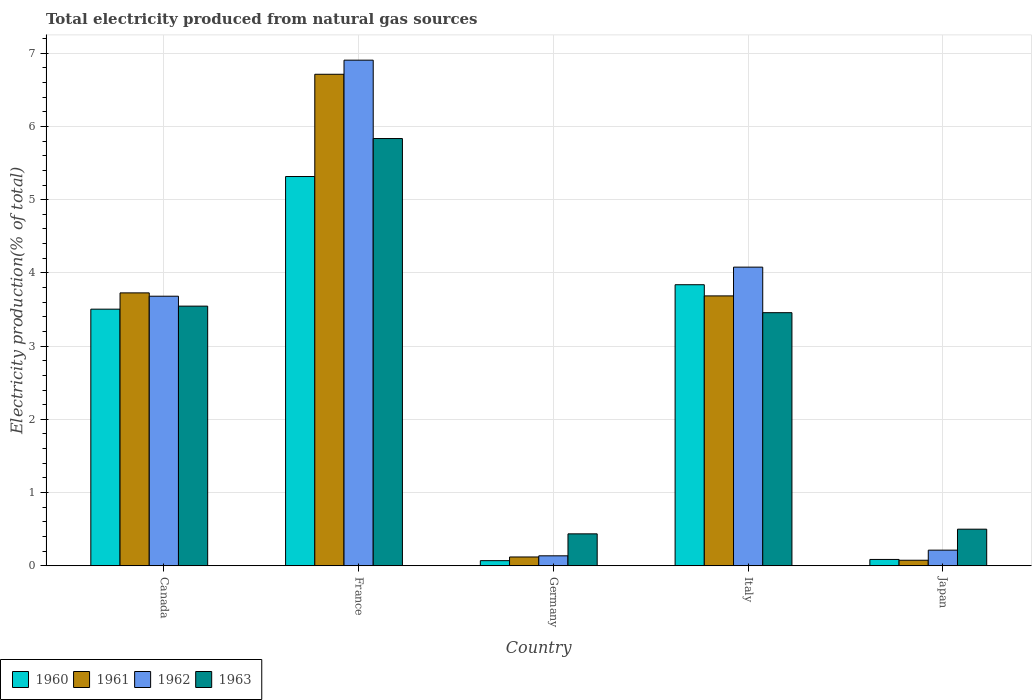How many different coloured bars are there?
Keep it short and to the point. 4. How many bars are there on the 4th tick from the right?
Make the answer very short. 4. What is the total electricity produced in 1961 in Japan?
Your answer should be compact. 0.08. Across all countries, what is the maximum total electricity produced in 1962?
Offer a terse response. 6.91. Across all countries, what is the minimum total electricity produced in 1961?
Offer a very short reply. 0.08. In which country was the total electricity produced in 1961 minimum?
Offer a very short reply. Japan. What is the total total electricity produced in 1963 in the graph?
Offer a terse response. 13.77. What is the difference between the total electricity produced in 1963 in Italy and that in Japan?
Your response must be concise. 2.96. What is the difference between the total electricity produced in 1962 in France and the total electricity produced in 1960 in Germany?
Your response must be concise. 6.83. What is the average total electricity produced in 1960 per country?
Provide a succinct answer. 2.56. What is the difference between the total electricity produced of/in 1962 and total electricity produced of/in 1961 in Germany?
Offer a very short reply. 0.02. What is the ratio of the total electricity produced in 1962 in France to that in Germany?
Provide a short and direct response. 50.69. What is the difference between the highest and the second highest total electricity produced in 1962?
Keep it short and to the point. -0.4. What is the difference between the highest and the lowest total electricity produced in 1963?
Offer a terse response. 5.4. In how many countries, is the total electricity produced in 1963 greater than the average total electricity produced in 1963 taken over all countries?
Provide a succinct answer. 3. Is the sum of the total electricity produced in 1962 in France and Japan greater than the maximum total electricity produced in 1963 across all countries?
Offer a terse response. Yes. Is it the case that in every country, the sum of the total electricity produced in 1960 and total electricity produced in 1963 is greater than the sum of total electricity produced in 1962 and total electricity produced in 1961?
Offer a terse response. No. What does the 4th bar from the left in Germany represents?
Your answer should be very brief. 1963. What does the 4th bar from the right in Italy represents?
Your answer should be very brief. 1960. Are all the bars in the graph horizontal?
Your answer should be very brief. No. How many countries are there in the graph?
Your response must be concise. 5. Are the values on the major ticks of Y-axis written in scientific E-notation?
Your response must be concise. No. Does the graph contain any zero values?
Your response must be concise. No. Does the graph contain grids?
Make the answer very short. Yes. Where does the legend appear in the graph?
Offer a terse response. Bottom left. How many legend labels are there?
Your response must be concise. 4. How are the legend labels stacked?
Keep it short and to the point. Horizontal. What is the title of the graph?
Keep it short and to the point. Total electricity produced from natural gas sources. Does "1994" appear as one of the legend labels in the graph?
Your answer should be very brief. No. What is the Electricity production(% of total) in 1960 in Canada?
Your response must be concise. 3.5. What is the Electricity production(% of total) of 1961 in Canada?
Ensure brevity in your answer.  3.73. What is the Electricity production(% of total) in 1962 in Canada?
Make the answer very short. 3.68. What is the Electricity production(% of total) of 1963 in Canada?
Provide a short and direct response. 3.55. What is the Electricity production(% of total) of 1960 in France?
Ensure brevity in your answer.  5.32. What is the Electricity production(% of total) in 1961 in France?
Ensure brevity in your answer.  6.71. What is the Electricity production(% of total) in 1962 in France?
Your answer should be very brief. 6.91. What is the Electricity production(% of total) in 1963 in France?
Your answer should be compact. 5.83. What is the Electricity production(% of total) in 1960 in Germany?
Keep it short and to the point. 0.07. What is the Electricity production(% of total) in 1961 in Germany?
Provide a succinct answer. 0.12. What is the Electricity production(% of total) of 1962 in Germany?
Make the answer very short. 0.14. What is the Electricity production(% of total) of 1963 in Germany?
Your answer should be very brief. 0.44. What is the Electricity production(% of total) in 1960 in Italy?
Keep it short and to the point. 3.84. What is the Electricity production(% of total) of 1961 in Italy?
Give a very brief answer. 3.69. What is the Electricity production(% of total) of 1962 in Italy?
Ensure brevity in your answer.  4.08. What is the Electricity production(% of total) of 1963 in Italy?
Keep it short and to the point. 3.46. What is the Electricity production(% of total) of 1960 in Japan?
Your response must be concise. 0.09. What is the Electricity production(% of total) of 1961 in Japan?
Your response must be concise. 0.08. What is the Electricity production(% of total) of 1962 in Japan?
Make the answer very short. 0.21. What is the Electricity production(% of total) of 1963 in Japan?
Offer a very short reply. 0.5. Across all countries, what is the maximum Electricity production(% of total) of 1960?
Keep it short and to the point. 5.32. Across all countries, what is the maximum Electricity production(% of total) in 1961?
Offer a terse response. 6.71. Across all countries, what is the maximum Electricity production(% of total) in 1962?
Give a very brief answer. 6.91. Across all countries, what is the maximum Electricity production(% of total) of 1963?
Provide a short and direct response. 5.83. Across all countries, what is the minimum Electricity production(% of total) of 1960?
Provide a succinct answer. 0.07. Across all countries, what is the minimum Electricity production(% of total) of 1961?
Provide a short and direct response. 0.08. Across all countries, what is the minimum Electricity production(% of total) of 1962?
Make the answer very short. 0.14. Across all countries, what is the minimum Electricity production(% of total) of 1963?
Make the answer very short. 0.44. What is the total Electricity production(% of total) in 1960 in the graph?
Provide a short and direct response. 12.82. What is the total Electricity production(% of total) in 1961 in the graph?
Give a very brief answer. 14.32. What is the total Electricity production(% of total) of 1962 in the graph?
Provide a succinct answer. 15.01. What is the total Electricity production(% of total) of 1963 in the graph?
Your response must be concise. 13.77. What is the difference between the Electricity production(% of total) in 1960 in Canada and that in France?
Provide a short and direct response. -1.81. What is the difference between the Electricity production(% of total) of 1961 in Canada and that in France?
Offer a very short reply. -2.99. What is the difference between the Electricity production(% of total) in 1962 in Canada and that in France?
Your response must be concise. -3.22. What is the difference between the Electricity production(% of total) of 1963 in Canada and that in France?
Offer a very short reply. -2.29. What is the difference between the Electricity production(% of total) in 1960 in Canada and that in Germany?
Provide a short and direct response. 3.43. What is the difference between the Electricity production(% of total) in 1961 in Canada and that in Germany?
Ensure brevity in your answer.  3.61. What is the difference between the Electricity production(% of total) in 1962 in Canada and that in Germany?
Make the answer very short. 3.55. What is the difference between the Electricity production(% of total) in 1963 in Canada and that in Germany?
Offer a very short reply. 3.11. What is the difference between the Electricity production(% of total) of 1960 in Canada and that in Italy?
Ensure brevity in your answer.  -0.33. What is the difference between the Electricity production(% of total) of 1961 in Canada and that in Italy?
Ensure brevity in your answer.  0.04. What is the difference between the Electricity production(% of total) of 1962 in Canada and that in Italy?
Give a very brief answer. -0.4. What is the difference between the Electricity production(% of total) of 1963 in Canada and that in Italy?
Offer a very short reply. 0.09. What is the difference between the Electricity production(% of total) in 1960 in Canada and that in Japan?
Your response must be concise. 3.42. What is the difference between the Electricity production(% of total) in 1961 in Canada and that in Japan?
Give a very brief answer. 3.65. What is the difference between the Electricity production(% of total) of 1962 in Canada and that in Japan?
Provide a succinct answer. 3.47. What is the difference between the Electricity production(% of total) of 1963 in Canada and that in Japan?
Ensure brevity in your answer.  3.05. What is the difference between the Electricity production(% of total) of 1960 in France and that in Germany?
Offer a very short reply. 5.25. What is the difference between the Electricity production(% of total) in 1961 in France and that in Germany?
Your answer should be compact. 6.59. What is the difference between the Electricity production(% of total) of 1962 in France and that in Germany?
Your answer should be compact. 6.77. What is the difference between the Electricity production(% of total) of 1963 in France and that in Germany?
Give a very brief answer. 5.4. What is the difference between the Electricity production(% of total) in 1960 in France and that in Italy?
Provide a succinct answer. 1.48. What is the difference between the Electricity production(% of total) in 1961 in France and that in Italy?
Make the answer very short. 3.03. What is the difference between the Electricity production(% of total) of 1962 in France and that in Italy?
Ensure brevity in your answer.  2.83. What is the difference between the Electricity production(% of total) in 1963 in France and that in Italy?
Provide a short and direct response. 2.38. What is the difference between the Electricity production(% of total) of 1960 in France and that in Japan?
Make the answer very short. 5.23. What is the difference between the Electricity production(% of total) in 1961 in France and that in Japan?
Give a very brief answer. 6.64. What is the difference between the Electricity production(% of total) in 1962 in France and that in Japan?
Provide a short and direct response. 6.69. What is the difference between the Electricity production(% of total) of 1963 in France and that in Japan?
Offer a very short reply. 5.33. What is the difference between the Electricity production(% of total) of 1960 in Germany and that in Italy?
Make the answer very short. -3.77. What is the difference between the Electricity production(% of total) in 1961 in Germany and that in Italy?
Provide a succinct answer. -3.57. What is the difference between the Electricity production(% of total) in 1962 in Germany and that in Italy?
Offer a very short reply. -3.94. What is the difference between the Electricity production(% of total) of 1963 in Germany and that in Italy?
Offer a terse response. -3.02. What is the difference between the Electricity production(% of total) in 1960 in Germany and that in Japan?
Offer a terse response. -0.02. What is the difference between the Electricity production(% of total) of 1961 in Germany and that in Japan?
Your response must be concise. 0.04. What is the difference between the Electricity production(% of total) in 1962 in Germany and that in Japan?
Keep it short and to the point. -0.08. What is the difference between the Electricity production(% of total) in 1963 in Germany and that in Japan?
Provide a short and direct response. -0.06. What is the difference between the Electricity production(% of total) of 1960 in Italy and that in Japan?
Offer a terse response. 3.75. What is the difference between the Electricity production(% of total) of 1961 in Italy and that in Japan?
Your answer should be very brief. 3.61. What is the difference between the Electricity production(% of total) in 1962 in Italy and that in Japan?
Your answer should be compact. 3.86. What is the difference between the Electricity production(% of total) in 1963 in Italy and that in Japan?
Make the answer very short. 2.96. What is the difference between the Electricity production(% of total) in 1960 in Canada and the Electricity production(% of total) in 1961 in France?
Provide a succinct answer. -3.21. What is the difference between the Electricity production(% of total) of 1960 in Canada and the Electricity production(% of total) of 1962 in France?
Your response must be concise. -3.4. What is the difference between the Electricity production(% of total) in 1960 in Canada and the Electricity production(% of total) in 1963 in France?
Your answer should be compact. -2.33. What is the difference between the Electricity production(% of total) in 1961 in Canada and the Electricity production(% of total) in 1962 in France?
Offer a very short reply. -3.18. What is the difference between the Electricity production(% of total) in 1961 in Canada and the Electricity production(% of total) in 1963 in France?
Offer a terse response. -2.11. What is the difference between the Electricity production(% of total) in 1962 in Canada and the Electricity production(% of total) in 1963 in France?
Your answer should be compact. -2.15. What is the difference between the Electricity production(% of total) in 1960 in Canada and the Electricity production(% of total) in 1961 in Germany?
Offer a very short reply. 3.38. What is the difference between the Electricity production(% of total) in 1960 in Canada and the Electricity production(% of total) in 1962 in Germany?
Give a very brief answer. 3.37. What is the difference between the Electricity production(% of total) of 1960 in Canada and the Electricity production(% of total) of 1963 in Germany?
Make the answer very short. 3.07. What is the difference between the Electricity production(% of total) in 1961 in Canada and the Electricity production(% of total) in 1962 in Germany?
Keep it short and to the point. 3.59. What is the difference between the Electricity production(% of total) in 1961 in Canada and the Electricity production(% of total) in 1963 in Germany?
Your answer should be compact. 3.29. What is the difference between the Electricity production(% of total) in 1962 in Canada and the Electricity production(% of total) in 1963 in Germany?
Keep it short and to the point. 3.25. What is the difference between the Electricity production(% of total) in 1960 in Canada and the Electricity production(% of total) in 1961 in Italy?
Keep it short and to the point. -0.18. What is the difference between the Electricity production(% of total) of 1960 in Canada and the Electricity production(% of total) of 1962 in Italy?
Ensure brevity in your answer.  -0.57. What is the difference between the Electricity production(% of total) of 1960 in Canada and the Electricity production(% of total) of 1963 in Italy?
Your answer should be very brief. 0.05. What is the difference between the Electricity production(% of total) of 1961 in Canada and the Electricity production(% of total) of 1962 in Italy?
Offer a very short reply. -0.35. What is the difference between the Electricity production(% of total) in 1961 in Canada and the Electricity production(% of total) in 1963 in Italy?
Make the answer very short. 0.27. What is the difference between the Electricity production(% of total) of 1962 in Canada and the Electricity production(% of total) of 1963 in Italy?
Make the answer very short. 0.23. What is the difference between the Electricity production(% of total) of 1960 in Canada and the Electricity production(% of total) of 1961 in Japan?
Give a very brief answer. 3.43. What is the difference between the Electricity production(% of total) in 1960 in Canada and the Electricity production(% of total) in 1962 in Japan?
Your answer should be very brief. 3.29. What is the difference between the Electricity production(% of total) in 1960 in Canada and the Electricity production(% of total) in 1963 in Japan?
Offer a very short reply. 3. What is the difference between the Electricity production(% of total) in 1961 in Canada and the Electricity production(% of total) in 1962 in Japan?
Make the answer very short. 3.51. What is the difference between the Electricity production(% of total) in 1961 in Canada and the Electricity production(% of total) in 1963 in Japan?
Offer a terse response. 3.23. What is the difference between the Electricity production(% of total) of 1962 in Canada and the Electricity production(% of total) of 1963 in Japan?
Offer a very short reply. 3.18. What is the difference between the Electricity production(% of total) of 1960 in France and the Electricity production(% of total) of 1961 in Germany?
Keep it short and to the point. 5.2. What is the difference between the Electricity production(% of total) of 1960 in France and the Electricity production(% of total) of 1962 in Germany?
Your answer should be very brief. 5.18. What is the difference between the Electricity production(% of total) of 1960 in France and the Electricity production(% of total) of 1963 in Germany?
Make the answer very short. 4.88. What is the difference between the Electricity production(% of total) in 1961 in France and the Electricity production(% of total) in 1962 in Germany?
Provide a short and direct response. 6.58. What is the difference between the Electricity production(% of total) in 1961 in France and the Electricity production(% of total) in 1963 in Germany?
Provide a succinct answer. 6.28. What is the difference between the Electricity production(% of total) of 1962 in France and the Electricity production(% of total) of 1963 in Germany?
Provide a short and direct response. 6.47. What is the difference between the Electricity production(% of total) in 1960 in France and the Electricity production(% of total) in 1961 in Italy?
Offer a very short reply. 1.63. What is the difference between the Electricity production(% of total) of 1960 in France and the Electricity production(% of total) of 1962 in Italy?
Your response must be concise. 1.24. What is the difference between the Electricity production(% of total) in 1960 in France and the Electricity production(% of total) in 1963 in Italy?
Your response must be concise. 1.86. What is the difference between the Electricity production(% of total) in 1961 in France and the Electricity production(% of total) in 1962 in Italy?
Your response must be concise. 2.63. What is the difference between the Electricity production(% of total) in 1961 in France and the Electricity production(% of total) in 1963 in Italy?
Give a very brief answer. 3.26. What is the difference between the Electricity production(% of total) of 1962 in France and the Electricity production(% of total) of 1963 in Italy?
Your response must be concise. 3.45. What is the difference between the Electricity production(% of total) of 1960 in France and the Electricity production(% of total) of 1961 in Japan?
Provide a succinct answer. 5.24. What is the difference between the Electricity production(% of total) of 1960 in France and the Electricity production(% of total) of 1962 in Japan?
Keep it short and to the point. 5.1. What is the difference between the Electricity production(% of total) of 1960 in France and the Electricity production(% of total) of 1963 in Japan?
Make the answer very short. 4.82. What is the difference between the Electricity production(% of total) of 1961 in France and the Electricity production(% of total) of 1962 in Japan?
Make the answer very short. 6.5. What is the difference between the Electricity production(% of total) in 1961 in France and the Electricity production(% of total) in 1963 in Japan?
Offer a very short reply. 6.21. What is the difference between the Electricity production(% of total) of 1962 in France and the Electricity production(% of total) of 1963 in Japan?
Provide a succinct answer. 6.4. What is the difference between the Electricity production(% of total) in 1960 in Germany and the Electricity production(% of total) in 1961 in Italy?
Keep it short and to the point. -3.62. What is the difference between the Electricity production(% of total) in 1960 in Germany and the Electricity production(% of total) in 1962 in Italy?
Your response must be concise. -4.01. What is the difference between the Electricity production(% of total) of 1960 in Germany and the Electricity production(% of total) of 1963 in Italy?
Offer a terse response. -3.39. What is the difference between the Electricity production(% of total) of 1961 in Germany and the Electricity production(% of total) of 1962 in Italy?
Make the answer very short. -3.96. What is the difference between the Electricity production(% of total) in 1961 in Germany and the Electricity production(% of total) in 1963 in Italy?
Make the answer very short. -3.34. What is the difference between the Electricity production(% of total) of 1962 in Germany and the Electricity production(% of total) of 1963 in Italy?
Give a very brief answer. -3.32. What is the difference between the Electricity production(% of total) in 1960 in Germany and the Electricity production(% of total) in 1961 in Japan?
Make the answer very short. -0.01. What is the difference between the Electricity production(% of total) in 1960 in Germany and the Electricity production(% of total) in 1962 in Japan?
Offer a terse response. -0.14. What is the difference between the Electricity production(% of total) in 1960 in Germany and the Electricity production(% of total) in 1963 in Japan?
Provide a short and direct response. -0.43. What is the difference between the Electricity production(% of total) of 1961 in Germany and the Electricity production(% of total) of 1962 in Japan?
Make the answer very short. -0.09. What is the difference between the Electricity production(% of total) of 1961 in Germany and the Electricity production(% of total) of 1963 in Japan?
Offer a terse response. -0.38. What is the difference between the Electricity production(% of total) of 1962 in Germany and the Electricity production(% of total) of 1963 in Japan?
Provide a short and direct response. -0.36. What is the difference between the Electricity production(% of total) in 1960 in Italy and the Electricity production(% of total) in 1961 in Japan?
Offer a terse response. 3.76. What is the difference between the Electricity production(% of total) of 1960 in Italy and the Electricity production(% of total) of 1962 in Japan?
Your response must be concise. 3.62. What is the difference between the Electricity production(% of total) in 1960 in Italy and the Electricity production(% of total) in 1963 in Japan?
Offer a very short reply. 3.34. What is the difference between the Electricity production(% of total) of 1961 in Italy and the Electricity production(% of total) of 1962 in Japan?
Your response must be concise. 3.47. What is the difference between the Electricity production(% of total) of 1961 in Italy and the Electricity production(% of total) of 1963 in Japan?
Keep it short and to the point. 3.19. What is the difference between the Electricity production(% of total) of 1962 in Italy and the Electricity production(% of total) of 1963 in Japan?
Provide a succinct answer. 3.58. What is the average Electricity production(% of total) of 1960 per country?
Provide a short and direct response. 2.56. What is the average Electricity production(% of total) in 1961 per country?
Your response must be concise. 2.86. What is the average Electricity production(% of total) in 1962 per country?
Provide a succinct answer. 3. What is the average Electricity production(% of total) of 1963 per country?
Your response must be concise. 2.75. What is the difference between the Electricity production(% of total) in 1960 and Electricity production(% of total) in 1961 in Canada?
Ensure brevity in your answer.  -0.22. What is the difference between the Electricity production(% of total) in 1960 and Electricity production(% of total) in 1962 in Canada?
Your answer should be compact. -0.18. What is the difference between the Electricity production(% of total) in 1960 and Electricity production(% of total) in 1963 in Canada?
Ensure brevity in your answer.  -0.04. What is the difference between the Electricity production(% of total) in 1961 and Electricity production(% of total) in 1962 in Canada?
Keep it short and to the point. 0.05. What is the difference between the Electricity production(% of total) of 1961 and Electricity production(% of total) of 1963 in Canada?
Ensure brevity in your answer.  0.18. What is the difference between the Electricity production(% of total) of 1962 and Electricity production(% of total) of 1963 in Canada?
Ensure brevity in your answer.  0.14. What is the difference between the Electricity production(% of total) of 1960 and Electricity production(% of total) of 1961 in France?
Make the answer very short. -1.4. What is the difference between the Electricity production(% of total) of 1960 and Electricity production(% of total) of 1962 in France?
Offer a very short reply. -1.59. What is the difference between the Electricity production(% of total) of 1960 and Electricity production(% of total) of 1963 in France?
Your response must be concise. -0.52. What is the difference between the Electricity production(% of total) in 1961 and Electricity production(% of total) in 1962 in France?
Provide a succinct answer. -0.19. What is the difference between the Electricity production(% of total) in 1961 and Electricity production(% of total) in 1963 in France?
Ensure brevity in your answer.  0.88. What is the difference between the Electricity production(% of total) of 1962 and Electricity production(% of total) of 1963 in France?
Your answer should be compact. 1.07. What is the difference between the Electricity production(% of total) of 1960 and Electricity production(% of total) of 1961 in Germany?
Give a very brief answer. -0.05. What is the difference between the Electricity production(% of total) of 1960 and Electricity production(% of total) of 1962 in Germany?
Your response must be concise. -0.07. What is the difference between the Electricity production(% of total) in 1960 and Electricity production(% of total) in 1963 in Germany?
Your answer should be very brief. -0.37. What is the difference between the Electricity production(% of total) of 1961 and Electricity production(% of total) of 1962 in Germany?
Your answer should be very brief. -0.02. What is the difference between the Electricity production(% of total) in 1961 and Electricity production(% of total) in 1963 in Germany?
Your answer should be very brief. -0.32. What is the difference between the Electricity production(% of total) in 1962 and Electricity production(% of total) in 1963 in Germany?
Offer a terse response. -0.3. What is the difference between the Electricity production(% of total) of 1960 and Electricity production(% of total) of 1961 in Italy?
Provide a short and direct response. 0.15. What is the difference between the Electricity production(% of total) in 1960 and Electricity production(% of total) in 1962 in Italy?
Your answer should be very brief. -0.24. What is the difference between the Electricity production(% of total) in 1960 and Electricity production(% of total) in 1963 in Italy?
Ensure brevity in your answer.  0.38. What is the difference between the Electricity production(% of total) in 1961 and Electricity production(% of total) in 1962 in Italy?
Make the answer very short. -0.39. What is the difference between the Electricity production(% of total) in 1961 and Electricity production(% of total) in 1963 in Italy?
Your answer should be compact. 0.23. What is the difference between the Electricity production(% of total) in 1962 and Electricity production(% of total) in 1963 in Italy?
Offer a terse response. 0.62. What is the difference between the Electricity production(% of total) in 1960 and Electricity production(% of total) in 1961 in Japan?
Provide a short and direct response. 0.01. What is the difference between the Electricity production(% of total) of 1960 and Electricity production(% of total) of 1962 in Japan?
Ensure brevity in your answer.  -0.13. What is the difference between the Electricity production(% of total) in 1960 and Electricity production(% of total) in 1963 in Japan?
Give a very brief answer. -0.41. What is the difference between the Electricity production(% of total) in 1961 and Electricity production(% of total) in 1962 in Japan?
Give a very brief answer. -0.14. What is the difference between the Electricity production(% of total) of 1961 and Electricity production(% of total) of 1963 in Japan?
Give a very brief answer. -0.42. What is the difference between the Electricity production(% of total) in 1962 and Electricity production(% of total) in 1963 in Japan?
Your answer should be very brief. -0.29. What is the ratio of the Electricity production(% of total) of 1960 in Canada to that in France?
Offer a terse response. 0.66. What is the ratio of the Electricity production(% of total) in 1961 in Canada to that in France?
Make the answer very short. 0.56. What is the ratio of the Electricity production(% of total) in 1962 in Canada to that in France?
Ensure brevity in your answer.  0.53. What is the ratio of the Electricity production(% of total) of 1963 in Canada to that in France?
Provide a short and direct response. 0.61. What is the ratio of the Electricity production(% of total) in 1960 in Canada to that in Germany?
Provide a succinct answer. 49.85. What is the ratio of the Electricity production(% of total) of 1961 in Canada to that in Germany?
Keep it short and to the point. 30.98. What is the ratio of the Electricity production(% of total) of 1962 in Canada to that in Germany?
Your answer should be very brief. 27.02. What is the ratio of the Electricity production(% of total) of 1963 in Canada to that in Germany?
Offer a terse response. 8.13. What is the ratio of the Electricity production(% of total) in 1960 in Canada to that in Italy?
Keep it short and to the point. 0.91. What is the ratio of the Electricity production(% of total) of 1961 in Canada to that in Italy?
Provide a short and direct response. 1.01. What is the ratio of the Electricity production(% of total) of 1962 in Canada to that in Italy?
Provide a succinct answer. 0.9. What is the ratio of the Electricity production(% of total) in 1963 in Canada to that in Italy?
Your answer should be very brief. 1.03. What is the ratio of the Electricity production(% of total) of 1960 in Canada to that in Japan?
Your answer should be very brief. 40.48. What is the ratio of the Electricity production(% of total) in 1961 in Canada to that in Japan?
Offer a very short reply. 49.23. What is the ratio of the Electricity production(% of total) of 1962 in Canada to that in Japan?
Offer a very short reply. 17.23. What is the ratio of the Electricity production(% of total) of 1963 in Canada to that in Japan?
Your answer should be compact. 7.09. What is the ratio of the Electricity production(% of total) in 1960 in France to that in Germany?
Ensure brevity in your answer.  75.62. What is the ratio of the Electricity production(% of total) of 1961 in France to that in Germany?
Offer a terse response. 55.79. What is the ratio of the Electricity production(% of total) in 1962 in France to that in Germany?
Make the answer very short. 50.69. What is the ratio of the Electricity production(% of total) of 1963 in France to that in Germany?
Provide a short and direct response. 13.38. What is the ratio of the Electricity production(% of total) of 1960 in France to that in Italy?
Give a very brief answer. 1.39. What is the ratio of the Electricity production(% of total) in 1961 in France to that in Italy?
Make the answer very short. 1.82. What is the ratio of the Electricity production(% of total) in 1962 in France to that in Italy?
Provide a short and direct response. 1.69. What is the ratio of the Electricity production(% of total) in 1963 in France to that in Italy?
Your response must be concise. 1.69. What is the ratio of the Electricity production(% of total) in 1960 in France to that in Japan?
Your answer should be compact. 61.4. What is the ratio of the Electricity production(% of total) in 1961 in France to that in Japan?
Offer a very short reply. 88.67. What is the ratio of the Electricity production(% of total) in 1962 in France to that in Japan?
Make the answer very short. 32.32. What is the ratio of the Electricity production(% of total) of 1963 in France to that in Japan?
Your answer should be compact. 11.67. What is the ratio of the Electricity production(% of total) of 1960 in Germany to that in Italy?
Offer a very short reply. 0.02. What is the ratio of the Electricity production(% of total) in 1961 in Germany to that in Italy?
Provide a short and direct response. 0.03. What is the ratio of the Electricity production(% of total) of 1962 in Germany to that in Italy?
Provide a succinct answer. 0.03. What is the ratio of the Electricity production(% of total) of 1963 in Germany to that in Italy?
Provide a short and direct response. 0.13. What is the ratio of the Electricity production(% of total) in 1960 in Germany to that in Japan?
Your answer should be compact. 0.81. What is the ratio of the Electricity production(% of total) of 1961 in Germany to that in Japan?
Offer a very short reply. 1.59. What is the ratio of the Electricity production(% of total) in 1962 in Germany to that in Japan?
Provide a short and direct response. 0.64. What is the ratio of the Electricity production(% of total) in 1963 in Germany to that in Japan?
Your answer should be very brief. 0.87. What is the ratio of the Electricity production(% of total) in 1960 in Italy to that in Japan?
Make the answer very short. 44.33. What is the ratio of the Electricity production(% of total) in 1961 in Italy to that in Japan?
Your answer should be very brief. 48.69. What is the ratio of the Electricity production(% of total) in 1962 in Italy to that in Japan?
Provide a short and direct response. 19.09. What is the ratio of the Electricity production(% of total) of 1963 in Italy to that in Japan?
Your response must be concise. 6.91. What is the difference between the highest and the second highest Electricity production(% of total) of 1960?
Your answer should be very brief. 1.48. What is the difference between the highest and the second highest Electricity production(% of total) of 1961?
Ensure brevity in your answer.  2.99. What is the difference between the highest and the second highest Electricity production(% of total) in 1962?
Give a very brief answer. 2.83. What is the difference between the highest and the second highest Electricity production(% of total) of 1963?
Ensure brevity in your answer.  2.29. What is the difference between the highest and the lowest Electricity production(% of total) of 1960?
Your response must be concise. 5.25. What is the difference between the highest and the lowest Electricity production(% of total) of 1961?
Offer a very short reply. 6.64. What is the difference between the highest and the lowest Electricity production(% of total) in 1962?
Make the answer very short. 6.77. What is the difference between the highest and the lowest Electricity production(% of total) in 1963?
Give a very brief answer. 5.4. 